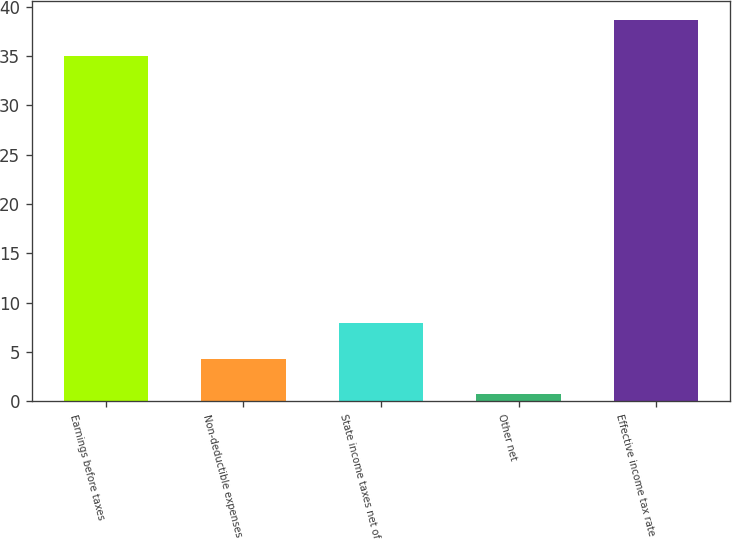Convert chart to OTSL. <chart><loc_0><loc_0><loc_500><loc_500><bar_chart><fcel>Earnings before taxes<fcel>Non-deductible expenses<fcel>State income taxes net of<fcel>Other net<fcel>Effective income tax rate<nl><fcel>35<fcel>4.33<fcel>7.96<fcel>0.7<fcel>38.63<nl></chart> 